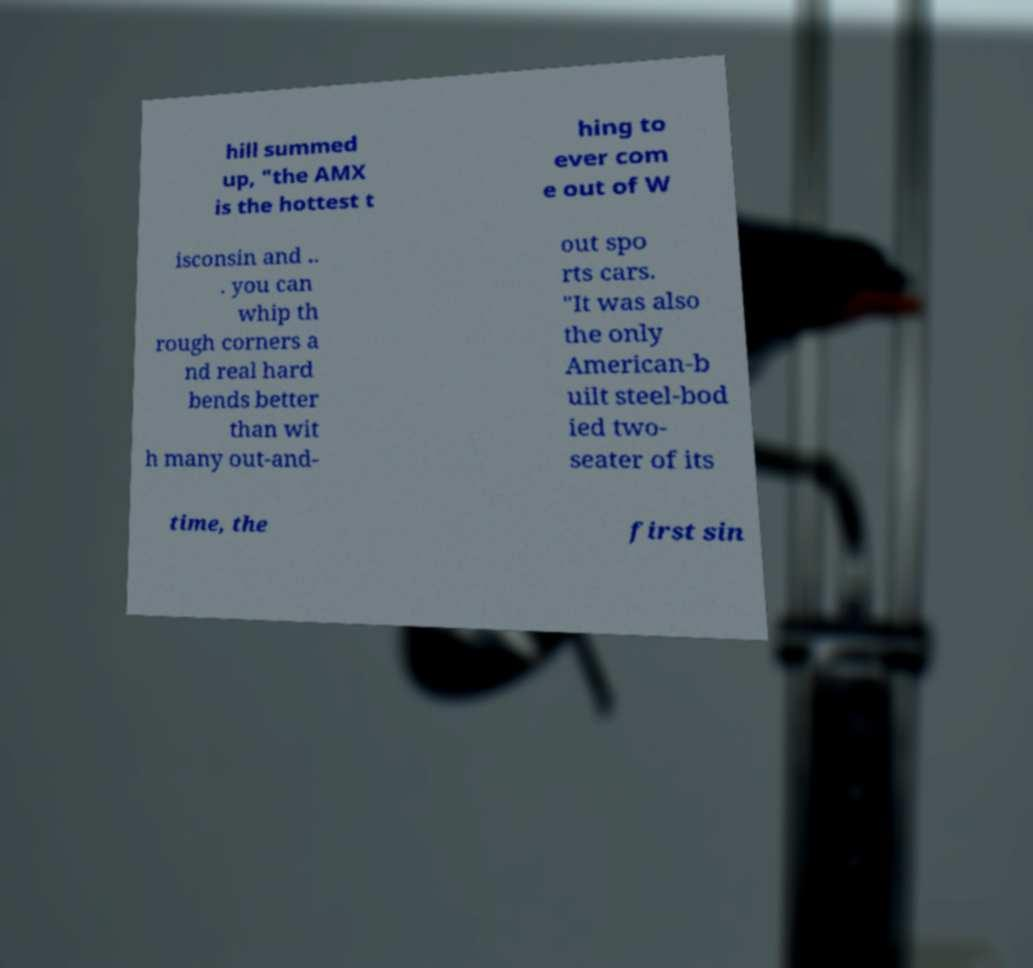Can you read and provide the text displayed in the image?This photo seems to have some interesting text. Can you extract and type it out for me? hill summed up, "the AMX is the hottest t hing to ever com e out of W isconsin and .. . you can whip th rough corners a nd real hard bends better than wit h many out-and- out spo rts cars. "It was also the only American-b uilt steel-bod ied two- seater of its time, the first sin 